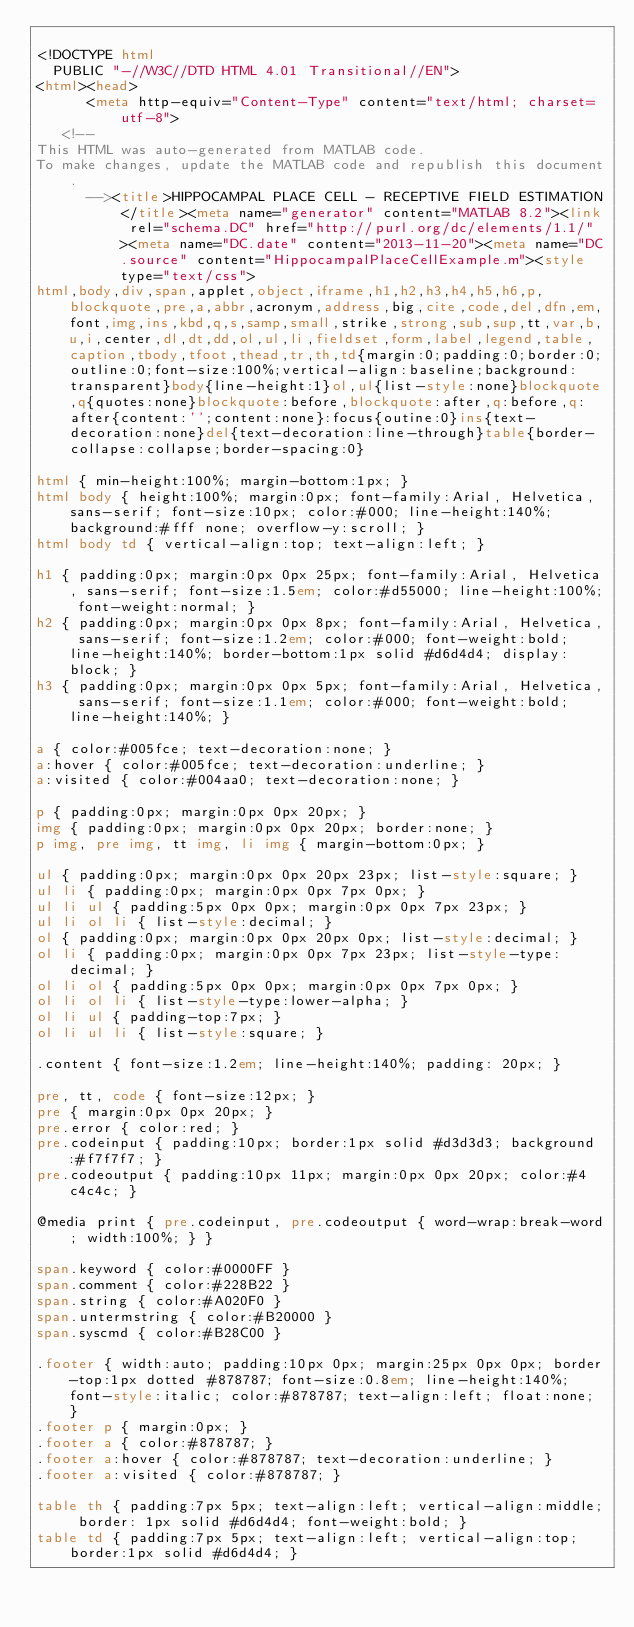Convert code to text. <code><loc_0><loc_0><loc_500><loc_500><_HTML_>
<!DOCTYPE html
  PUBLIC "-//W3C//DTD HTML 4.01 Transitional//EN">
<html><head>
      <meta http-equiv="Content-Type" content="text/html; charset=utf-8">
   <!--
This HTML was auto-generated from MATLAB code.
To make changes, update the MATLAB code and republish this document.
      --><title>HIPPOCAMPAL PLACE CELL - RECEPTIVE FIELD ESTIMATION</title><meta name="generator" content="MATLAB 8.2"><link rel="schema.DC" href="http://purl.org/dc/elements/1.1/"><meta name="DC.date" content="2013-11-20"><meta name="DC.source" content="HippocampalPlaceCellExample.m"><style type="text/css">
html,body,div,span,applet,object,iframe,h1,h2,h3,h4,h5,h6,p,blockquote,pre,a,abbr,acronym,address,big,cite,code,del,dfn,em,font,img,ins,kbd,q,s,samp,small,strike,strong,sub,sup,tt,var,b,u,i,center,dl,dt,dd,ol,ul,li,fieldset,form,label,legend,table,caption,tbody,tfoot,thead,tr,th,td{margin:0;padding:0;border:0;outline:0;font-size:100%;vertical-align:baseline;background:transparent}body{line-height:1}ol,ul{list-style:none}blockquote,q{quotes:none}blockquote:before,blockquote:after,q:before,q:after{content:'';content:none}:focus{outine:0}ins{text-decoration:none}del{text-decoration:line-through}table{border-collapse:collapse;border-spacing:0}

html { min-height:100%; margin-bottom:1px; }
html body { height:100%; margin:0px; font-family:Arial, Helvetica, sans-serif; font-size:10px; color:#000; line-height:140%; background:#fff none; overflow-y:scroll; }
html body td { vertical-align:top; text-align:left; }

h1 { padding:0px; margin:0px 0px 25px; font-family:Arial, Helvetica, sans-serif; font-size:1.5em; color:#d55000; line-height:100%; font-weight:normal; }
h2 { padding:0px; margin:0px 0px 8px; font-family:Arial, Helvetica, sans-serif; font-size:1.2em; color:#000; font-weight:bold; line-height:140%; border-bottom:1px solid #d6d4d4; display:block; }
h3 { padding:0px; margin:0px 0px 5px; font-family:Arial, Helvetica, sans-serif; font-size:1.1em; color:#000; font-weight:bold; line-height:140%; }

a { color:#005fce; text-decoration:none; }
a:hover { color:#005fce; text-decoration:underline; }
a:visited { color:#004aa0; text-decoration:none; }

p { padding:0px; margin:0px 0px 20px; }
img { padding:0px; margin:0px 0px 20px; border:none; }
p img, pre img, tt img, li img { margin-bottom:0px; } 

ul { padding:0px; margin:0px 0px 20px 23px; list-style:square; }
ul li { padding:0px; margin:0px 0px 7px 0px; }
ul li ul { padding:5px 0px 0px; margin:0px 0px 7px 23px; }
ul li ol li { list-style:decimal; }
ol { padding:0px; margin:0px 0px 20px 0px; list-style:decimal; }
ol li { padding:0px; margin:0px 0px 7px 23px; list-style-type:decimal; }
ol li ol { padding:5px 0px 0px; margin:0px 0px 7px 0px; }
ol li ol li { list-style-type:lower-alpha; }
ol li ul { padding-top:7px; }
ol li ul li { list-style:square; }

.content { font-size:1.2em; line-height:140%; padding: 20px; }

pre, tt, code { font-size:12px; }
pre { margin:0px 0px 20px; }
pre.error { color:red; }
pre.codeinput { padding:10px; border:1px solid #d3d3d3; background:#f7f7f7; }
pre.codeoutput { padding:10px 11px; margin:0px 0px 20px; color:#4c4c4c; }

@media print { pre.codeinput, pre.codeoutput { word-wrap:break-word; width:100%; } }

span.keyword { color:#0000FF }
span.comment { color:#228B22 }
span.string { color:#A020F0 }
span.untermstring { color:#B20000 }
span.syscmd { color:#B28C00 }

.footer { width:auto; padding:10px 0px; margin:25px 0px 0px; border-top:1px dotted #878787; font-size:0.8em; line-height:140%; font-style:italic; color:#878787; text-align:left; float:none; }
.footer p { margin:0px; }
.footer a { color:#878787; }
.footer a:hover { color:#878787; text-decoration:underline; }
.footer a:visited { color:#878787; }

table th { padding:7px 5px; text-align:left; vertical-align:middle; border: 1px solid #d6d4d4; font-weight:bold; }
table td { padding:7px 5px; text-align:left; vertical-align:top; border:1px solid #d6d4d4; }




</code> 